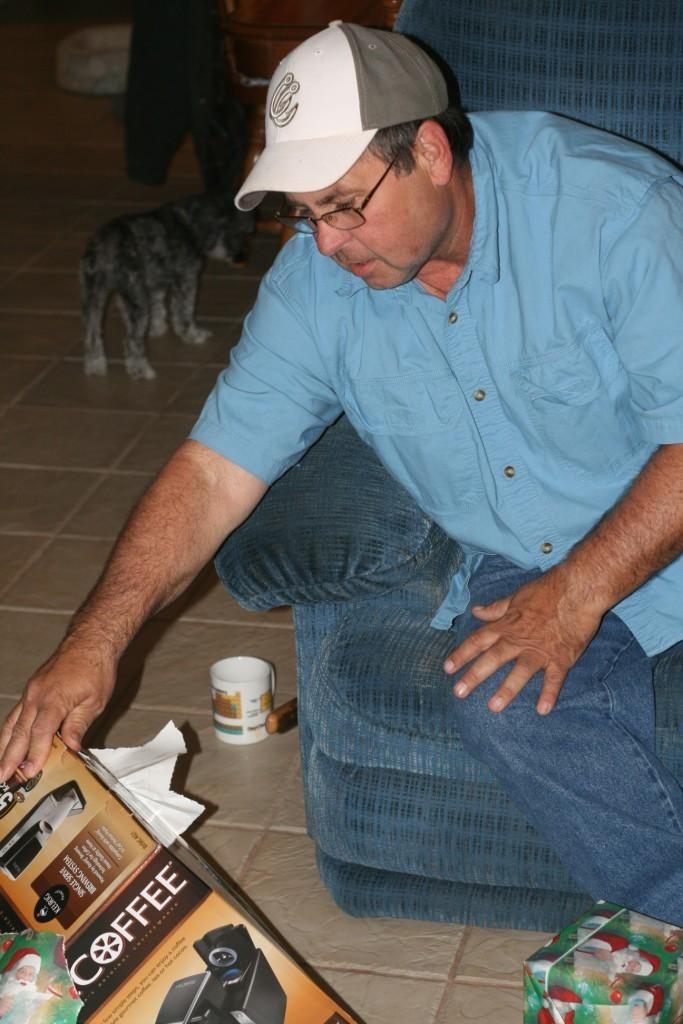How would you summarize this image in a sentence or two? A person is sitting wearing a cap, blue shirt and jeans. There is a box and other objects at the left. There is a dog at the back. 